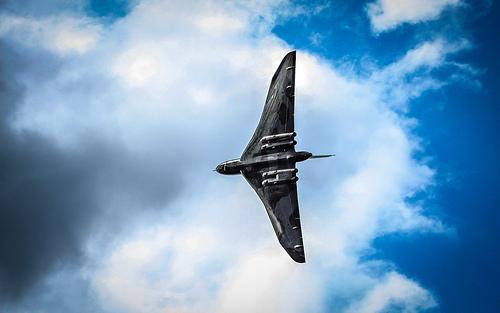How many planes are in the photo?
Give a very brief answer. 1. 